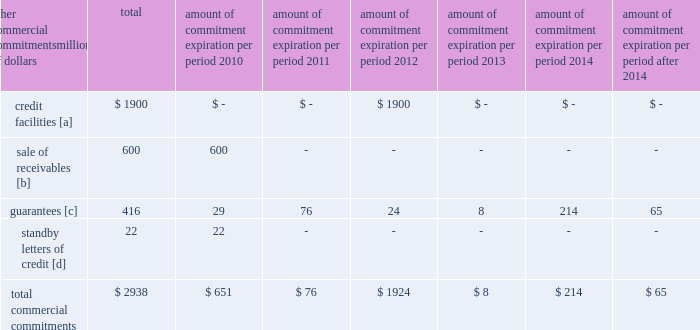Amount of commitment expiration per period other commercial commitments after millions of dollars total 2010 2011 2012 2013 2014 2014 .
[a] none of the credit facility was used as of december 31 , 2009 .
[b] $ 400 million of the sale of receivables program was utilized at december 31 , 2009 .
[c] includes guaranteed obligations related to our headquarters building , equipment financings , and affiliated operations .
[d] none of the letters of credit were drawn upon as of december 31 , 2009 .
Off-balance sheet arrangements sale of receivables 2013 the railroad transfers most of its accounts receivable to union pacific receivables , inc .
( upri ) , a bankruptcy-remote subsidiary , as part of a sale of receivables facility .
Upri sells , without recourse on a 364-day revolving basis , an undivided interest in such accounts receivable to investors .
The total capacity to sell undivided interests to investors under the facility was $ 600 million and $ 700 million at december 31 , 2009 and 2008 , respectively .
The value of the outstanding undivided interest held by investors under the facility was $ 400 million and $ 584 million at december 31 , 2009 and 2008 , respectively .
During 2009 , upri reduced the outstanding undivided interest held by investors due to a decrease in available receivables .
The value of the undivided interest held by investors is not included in our consolidated financial statements .
The value of the undivided interest held by investors was supported by $ 817 million and $ 1015 million of accounts receivable held by upri at december 31 , 2009 and 2008 , respectively .
At december 31 , 2009 and 2008 , the value of the interest retained by upri was $ 417 million and $ 431 million , respectively .
This retained interest is included in accounts receivable in our consolidated financial statements .
The interest sold to investors is sold at carrying value , which approximates fair value , and there is no gain or loss recognized from the transaction .
The value of the outstanding undivided interest held by investors could fluctuate based upon the availability of eligible receivables and is directly affected by changing business volumes and credit risks , including default and dilution .
If default or dilution ratios increase one percent , the value of the outstanding undivided interest held by investors would not change as of december 31 , 2009 .
Should our credit rating fall below investment grade , the value of the outstanding undivided interest held by investors would be reduced , and , in certain cases , the investors would have the right to discontinue the facility .
The railroad services the sold receivables ; however , the railroad does not recognize any servicing asset or liability , as the servicing fees adequately compensate us for these responsibilities .
The railroad collected approximately $ 13.8 billion and $ 17.8 billion during the years ended december 31 , 2009 and 2008 , respectively .
Upri used certain of these proceeds to purchase new receivables under the facility .
The costs of the sale of receivables program are included in other income and were $ 9 million , $ 23 million , and $ 35 million for 2009 , 2008 , and 2007 , respectively .
The costs include interest , which will vary based on prevailing commercial paper rates , program fees paid to banks , commercial paper issuing costs , and fees for unused commitment availability .
The decrease in the 2009 costs was primarily attributable to lower commercial paper rates and a decrease in the outstanding interest held by investors. .
What percentage of total commercial commitments are credit facilities? 
Computations: (1900 / 2938)
Answer: 0.6467. 